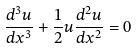Convert formula to latex. <formula><loc_0><loc_0><loc_500><loc_500>\frac { d ^ { 3 } u } { d x ^ { 3 } } + \frac { 1 } { 2 } u \frac { d ^ { 2 } u } { d x ^ { 2 } } = 0</formula> 